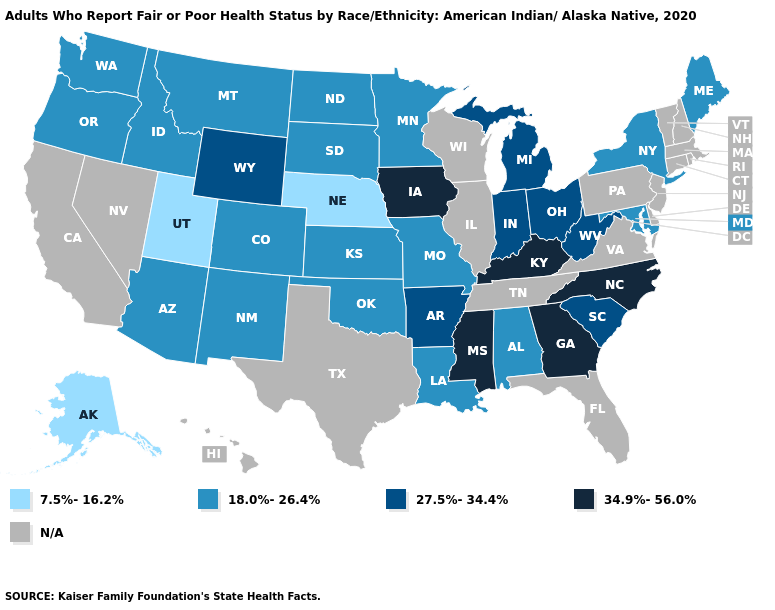Name the states that have a value in the range 7.5%-16.2%?
Give a very brief answer. Alaska, Nebraska, Utah. Name the states that have a value in the range 34.9%-56.0%?
Write a very short answer. Georgia, Iowa, Kentucky, Mississippi, North Carolina. What is the value of Indiana?
Write a very short answer. 27.5%-34.4%. Which states have the highest value in the USA?
Quick response, please. Georgia, Iowa, Kentucky, Mississippi, North Carolina. Name the states that have a value in the range N/A?
Be succinct. California, Connecticut, Delaware, Florida, Hawaii, Illinois, Massachusetts, Nevada, New Hampshire, New Jersey, Pennsylvania, Rhode Island, Tennessee, Texas, Vermont, Virginia, Wisconsin. Name the states that have a value in the range 34.9%-56.0%?
Write a very short answer. Georgia, Iowa, Kentucky, Mississippi, North Carolina. What is the lowest value in states that border Michigan?
Answer briefly. 27.5%-34.4%. What is the value of Wyoming?
Keep it brief. 27.5%-34.4%. Among the states that border Michigan , which have the highest value?
Write a very short answer. Indiana, Ohio. Name the states that have a value in the range 34.9%-56.0%?
Be succinct. Georgia, Iowa, Kentucky, Mississippi, North Carolina. Among the states that border Utah , which have the highest value?
Write a very short answer. Wyoming. Does the map have missing data?
Quick response, please. Yes. Which states have the lowest value in the MidWest?
Answer briefly. Nebraska. What is the highest value in the USA?
Give a very brief answer. 34.9%-56.0%. What is the highest value in the West ?
Short answer required. 27.5%-34.4%. 